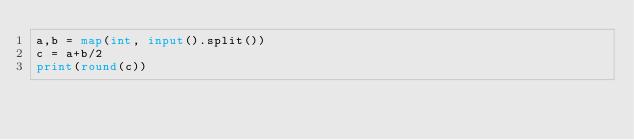<code> <loc_0><loc_0><loc_500><loc_500><_Python_>a,b = map(int, input().split())
c = a+b/2
print(round(c))</code> 